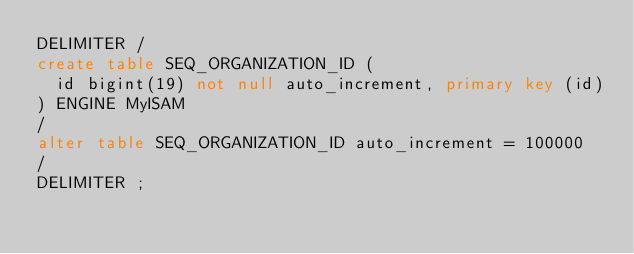<code> <loc_0><loc_0><loc_500><loc_500><_SQL_>DELIMITER /
create table SEQ_ORGANIZATION_ID (
  id bigint(19) not null auto_increment, primary key (id)
) ENGINE MyISAM
/
alter table SEQ_ORGANIZATION_ID auto_increment = 100000
/
DELIMITER ;
</code> 